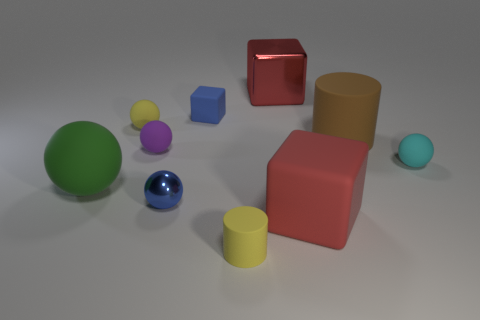Is the tiny metal thing the same color as the small rubber cube?
Your answer should be compact. Yes. There is a tiny matte ball behind the large matte cylinder; does it have the same color as the tiny cylinder?
Your response must be concise. Yes. How many rubber things have the same color as the small shiny ball?
Your answer should be very brief. 1. There is a shiny object in front of the metallic block; is it the same color as the matte block behind the big cylinder?
Make the answer very short. Yes. How many tiny rubber objects are on the right side of the small purple matte sphere and behind the purple matte thing?
Make the answer very short. 1. Is the red thing that is right of the big shiny block made of the same material as the small blue sphere?
Make the answer very short. No. The yellow matte thing that is in front of the green object left of the metal object behind the blue metallic ball is what shape?
Ensure brevity in your answer.  Cylinder. Is the number of large matte cylinders to the right of the large brown cylinder the same as the number of matte cubes that are in front of the small blue ball?
Give a very brief answer. No. There is a block that is the same size as the cyan thing; what color is it?
Provide a succinct answer. Blue. What number of big things are yellow rubber objects or blue metal spheres?
Offer a very short reply. 0. 